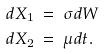<formula> <loc_0><loc_0><loc_500><loc_500>d X _ { 1 } & \ = \ \sigma d W \\ d X _ { 2 } & \ = \ \mu d t \text {.}</formula> 